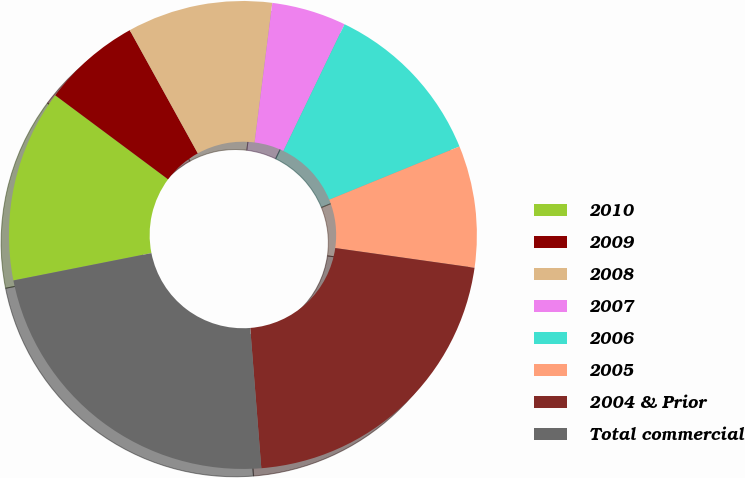<chart> <loc_0><loc_0><loc_500><loc_500><pie_chart><fcel>2010<fcel>2009<fcel>2008<fcel>2007<fcel>2006<fcel>2005<fcel>2004 & Prior<fcel>Total commercial<nl><fcel>13.3%<fcel>6.78%<fcel>10.04%<fcel>5.15%<fcel>11.67%<fcel>8.41%<fcel>21.51%<fcel>23.14%<nl></chart> 